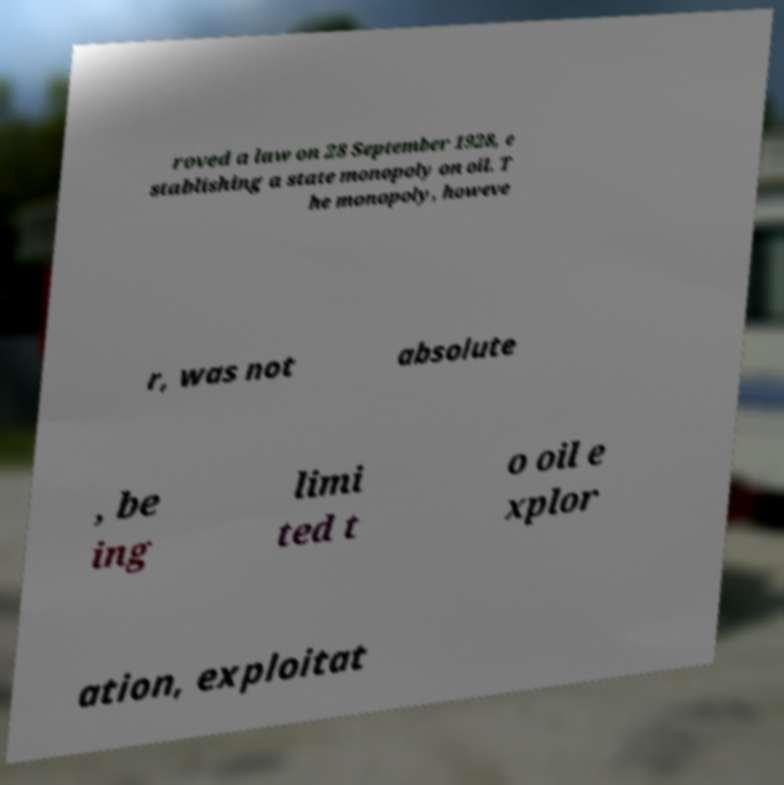Can you accurately transcribe the text from the provided image for me? roved a law on 28 September 1928, e stablishing a state monopoly on oil. T he monopoly, howeve r, was not absolute , be ing limi ted t o oil e xplor ation, exploitat 